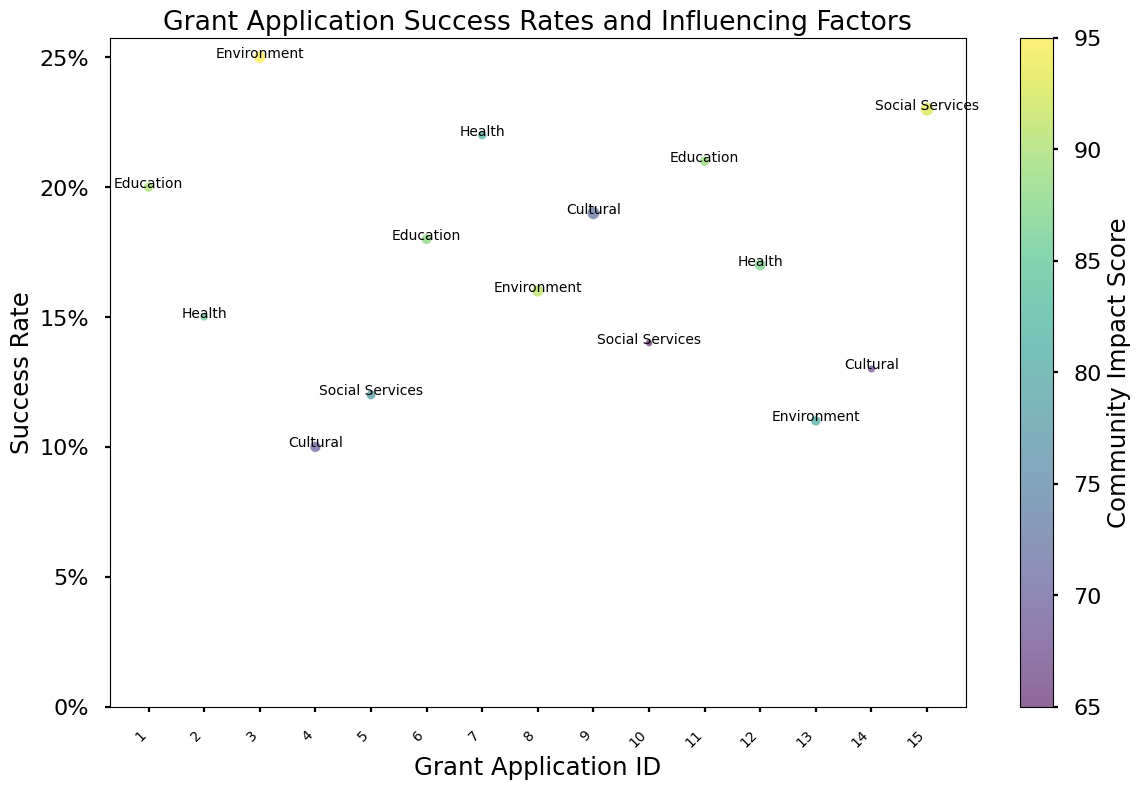What is the overall success rate for Health projects? To determine the overall success rate for Health projects, look for data points labeled "Health" and observe their corresponding success rates. From the chart, Health projects are plotted at success rates of 0.15 and 0.22. The average is calculated as (0.15 + 0.22) / 2 = 0.185.
Answer: 0.185 Which project type has the largest bubble size, indicating the highest funding amount requested? Bubble size represents the funding amount requested. Observe all the bubbles and identify the one with the largest size. From the figure, the "Social Services" project with grant ID 15 has the largest bubble size.
Answer: Social Services What is the success rate for the project type with the highest community impact score? The color intensity represents community impact score. Identify the project with the darkest bubble, then refer to its success rate and type annotation. The project labeled "Environment" with a success rate of 0.25 has the highest score (95).
Answer: 0.25 How does the success rate of Local projects compare to that of National projects? Identify bubbles representing Local projects and National projects, then compare their success rates. Local project rates are at 0.20, 0.10, and 0.22. National rates are at 0.25, 0.18, 0.19, and 0.17. Calculate the average: Local (0.20 + 0.10 + 0.22)/3 = 0.173, and National (0.25 + 0.18 + 0.19 + 0.17)/4 = 0.1975. National projects generally have a slightly higher average success rate.
Answer: National: 0.1975, Local: 0.173 What is the range of community impact scores represented in the chart? The color bar indicates community impact scores. Note the highest and lowest values shown in the figure. The darkest bubble indicates the highest score at 95, and the lightest bubble indicates the lowest score at 65. The range can be calculated as 95 - 65.
Answer: 30 Which project type has the lowest success rate, and what is its community impact score? Look for the bubble at the lowest position on the y-axis (success rate). The project labeled "Cultural" with a success rate of 0.10 has the lowest success rate. Its community impact score can be found from the color legend.
Answer: Cultural, 70 Is there a trend in success rates based on the geographical reach of the projects (Local, Regional, National)? Compare success rates for different geographical reaches by observing their color patterns and labels. Local projects have varying success rates (0.20, 0.10, 0.22). Regional projects have mixed results (0.15, 0.12, 0.16, 0.21). National projects generally show moderate-high success rates (0.25, 0.18, 0.19, 0.17, 0.23). There is no clear trend, rather a spread across all geographical reaches.
Answer: Mixed, no clear trend 